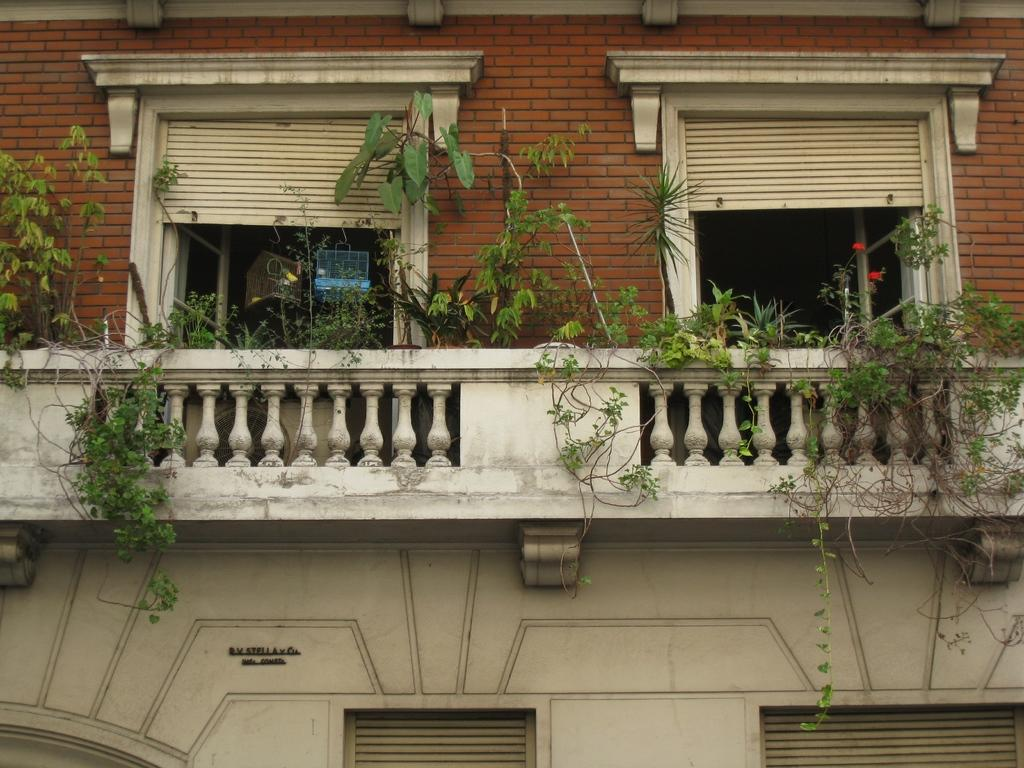What type of structure is present in the image? There is a house in the image. Where are the windows located on the house? The house has windows on both the right and left sides. What else can be seen in the image besides the house? There are plants visible in the image. What feature is present near the house? There is a railing in the image. How many dogs are participating in the amusement park scene in the image? There are no dogs or amusement park scenes present in the image. 